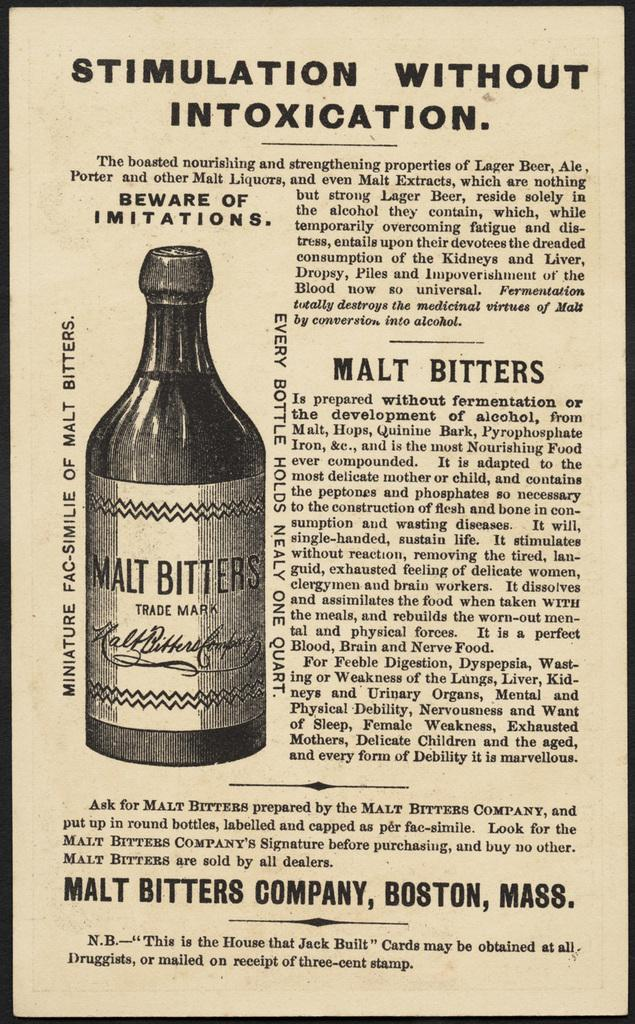<image>
Give a short and clear explanation of the subsequent image. An old black and white advert in a newspaper offering Malt Bitters which promises to make you feel good but not drunk. 